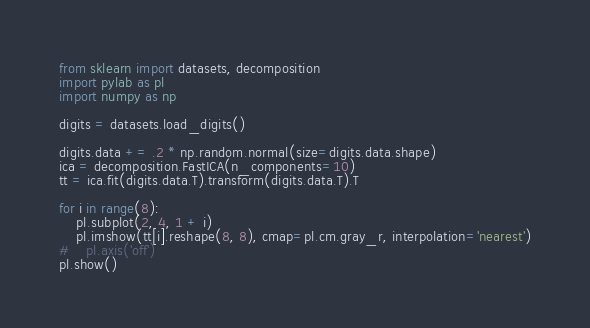<code> <loc_0><loc_0><loc_500><loc_500><_Python_>from sklearn import datasets, decomposition
import pylab as pl
import numpy as np

digits = datasets.load_digits()

digits.data += .2 * np.random.normal(size=digits.data.shape)
ica = decomposition.FastICA(n_components=10)
tt = ica.fit(digits.data.T).transform(digits.data.T).T

for i in range(8):
    pl.subplot(2, 4, 1 + i)
    pl.imshow(tt[i].reshape(8, 8), cmap=pl.cm.gray_r, interpolation='nearest')
#    pl.axis('off')
pl.show()
</code> 